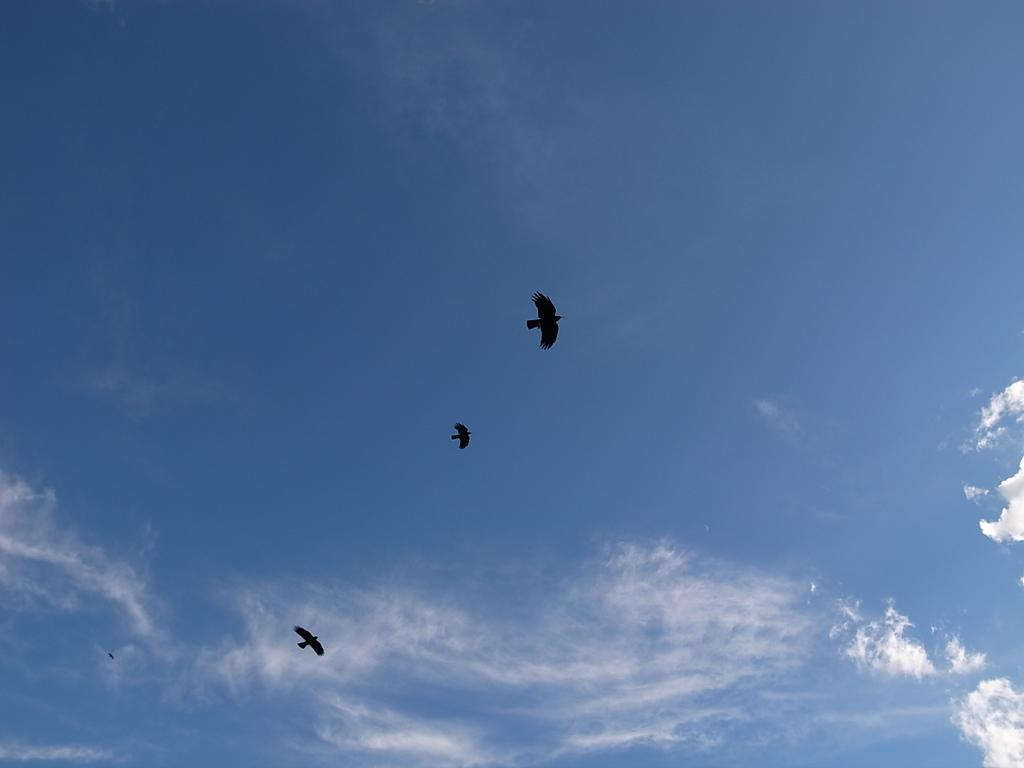What type of animals can be seen in the image? Birds can be seen in the image. What are the birds doing in the image? The birds are flying in the air. What type of jeans are the birds wearing in the image? There are no jeans present in the image, as birds do not wear clothing. 